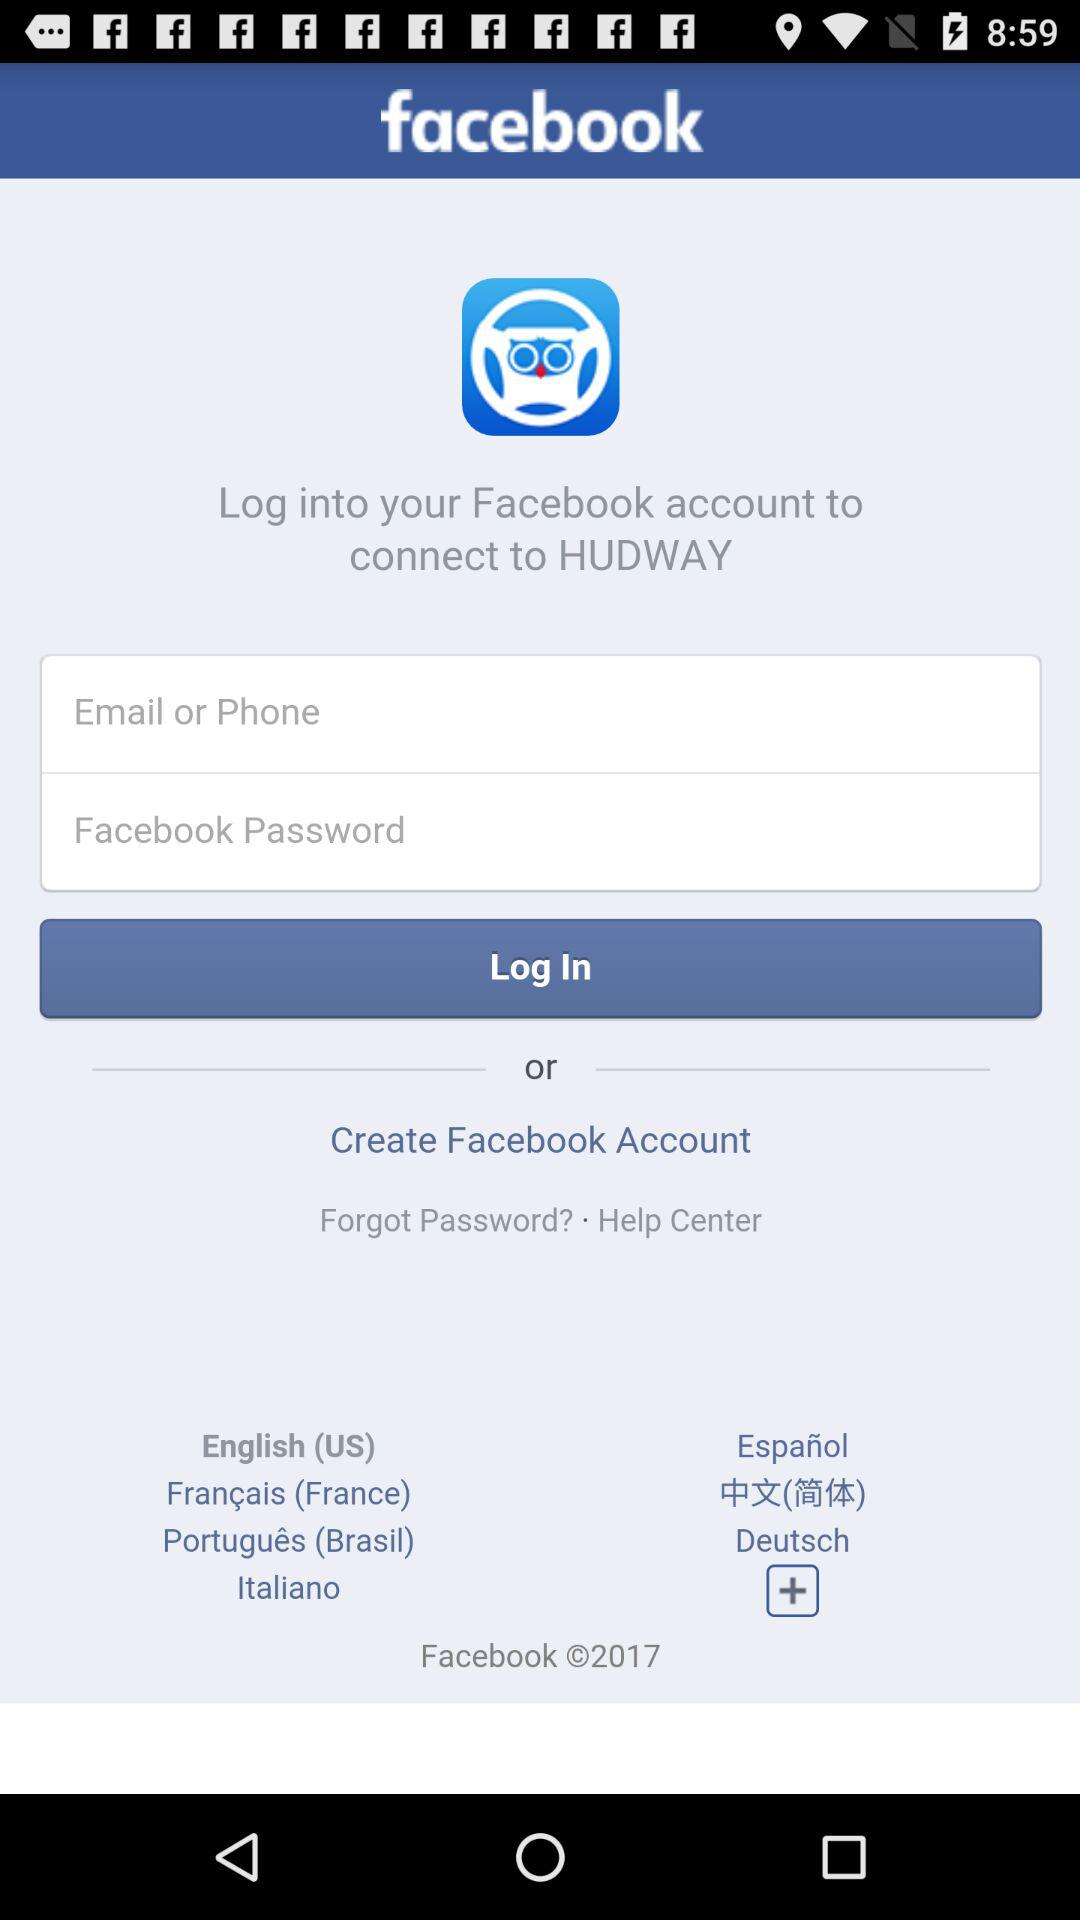How many input fields are there for logging into Facebook?
Answer the question using a single word or phrase. 2 